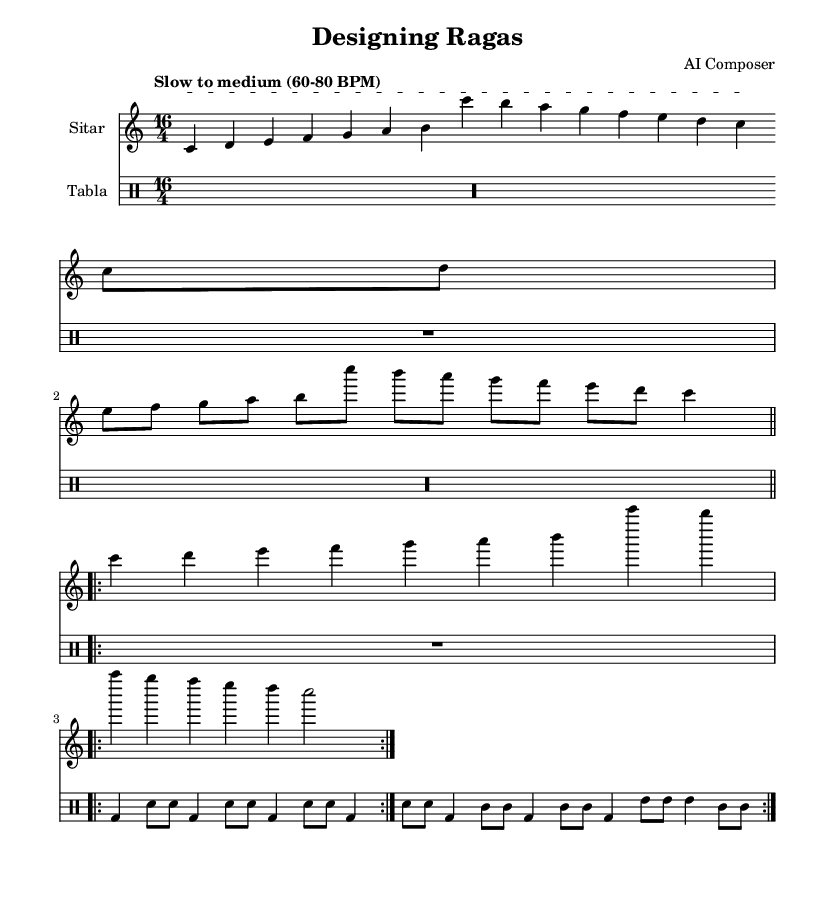What is the key signature of this music? The key signature is indicated by the notes in the scale throughout the sheet music. The absence of sharps or flats confirms that the key is C major.
Answer: C major What is the time signature of this music? The time signature is found at the beginning of the score, where it shows 16 over 4. This indicates that there are 16 beats in a measure, and each quarter note gets one beat.
Answer: 16/4 What is the tempo marking for this piece? The tempo marking is usually located above the staff and indicates the speed of the music. Here, it states "Slow to medium (60-80 BPM)."
Answer: Slow to medium (60-80 BPM) How many measures are in the Alap section for the sitar? To determine the number of measures, we look at the notated section for the sitar, which is divided clearly. The Alap is just one measure long indicated by the single line of notes before the break.
Answer: 1 How many times is the Gat repeated for the tabla? The symbol "volta 2" indicates that the section is repeated two times. This applies to both the sitar and tabla parts as indicated in the repeat section.
Answer: 2 What is the main rhythm pattern used in the Gat for the tabla? The rhythm pattern can be identified by the sequence of notes shown in the Gat section. The tabla rhythm consists of "bd, sn" and other notations that follow a specific sequence which reflects traditional Indian classical rhythms.
Answer: bd, sn What characterizes the Jor section in this composition? The Jor section is characterized by its more defined rhythm and progression, moving from slower notes to more rapid sequences, as seen in the score specifically through its increased pace compared to the Alap.
Answer: Defined rhythm 